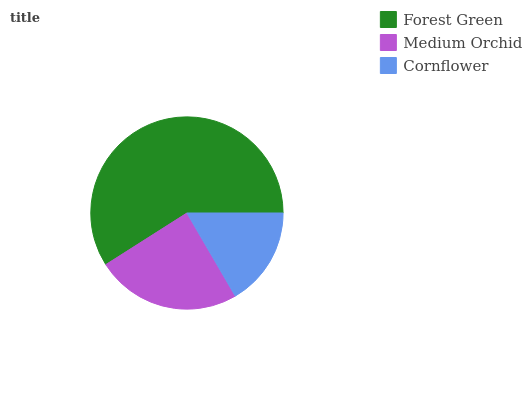Is Cornflower the minimum?
Answer yes or no. Yes. Is Forest Green the maximum?
Answer yes or no. Yes. Is Medium Orchid the minimum?
Answer yes or no. No. Is Medium Orchid the maximum?
Answer yes or no. No. Is Forest Green greater than Medium Orchid?
Answer yes or no. Yes. Is Medium Orchid less than Forest Green?
Answer yes or no. Yes. Is Medium Orchid greater than Forest Green?
Answer yes or no. No. Is Forest Green less than Medium Orchid?
Answer yes or no. No. Is Medium Orchid the high median?
Answer yes or no. Yes. Is Medium Orchid the low median?
Answer yes or no. Yes. Is Cornflower the high median?
Answer yes or no. No. Is Forest Green the low median?
Answer yes or no. No. 